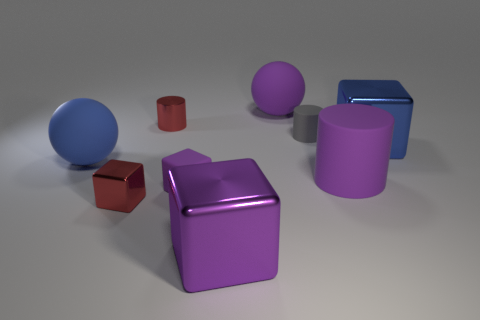What is the shape of the blue matte object?
Keep it short and to the point. Sphere. There is a big purple shiny thing; are there any tiny red shiny blocks in front of it?
Provide a succinct answer. No. Is the material of the big purple cylinder the same as the big cube that is in front of the purple matte cylinder?
Your response must be concise. No. Is the shape of the red metal object in front of the gray object the same as  the big blue metal object?
Keep it short and to the point. Yes. How many small objects are the same material as the tiny red cylinder?
Provide a short and direct response. 1. How many objects are big objects that are left of the big blue shiny object or big brown metal cylinders?
Give a very brief answer. 4. How big is the gray cylinder?
Your answer should be very brief. Small. The cylinder that is behind the matte cylinder that is behind the big rubber cylinder is made of what material?
Your response must be concise. Metal. Do the rubber thing behind the red shiny cylinder and the large blue metallic block have the same size?
Offer a very short reply. Yes. Is there a rubber cylinder that has the same color as the small rubber block?
Offer a terse response. Yes. 